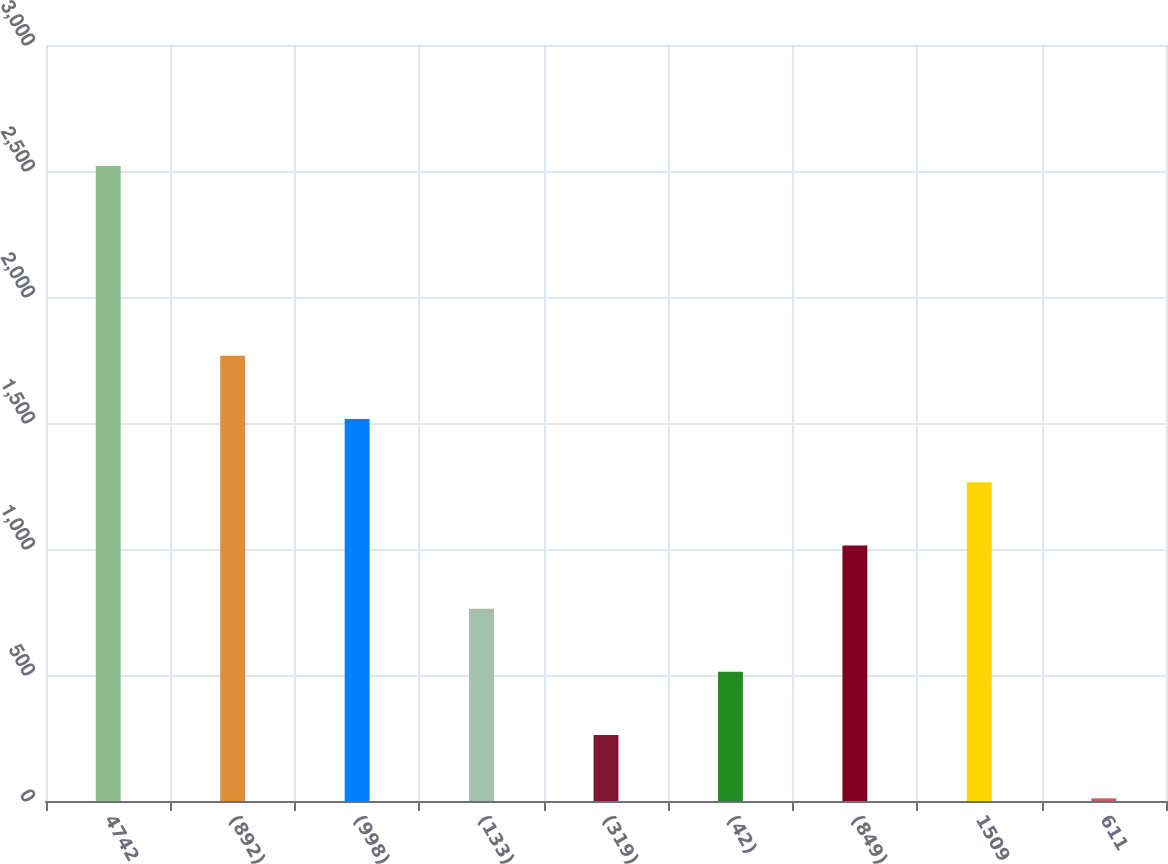<chart> <loc_0><loc_0><loc_500><loc_500><bar_chart><fcel>4742<fcel>(892)<fcel>(998)<fcel>(133)<fcel>(319)<fcel>(42)<fcel>(849)<fcel>1509<fcel>611<nl><fcel>2520<fcel>1767.16<fcel>1516.21<fcel>763.36<fcel>261.46<fcel>512.41<fcel>1014.31<fcel>1265.26<fcel>10.51<nl></chart> 